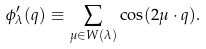<formula> <loc_0><loc_0><loc_500><loc_500>\phi _ { \lambda } ^ { \prime } ( q ) \equiv \sum _ { \mu \in W ( \lambda ) } \cos ( { 2 \mu \cdot q } ) .</formula> 